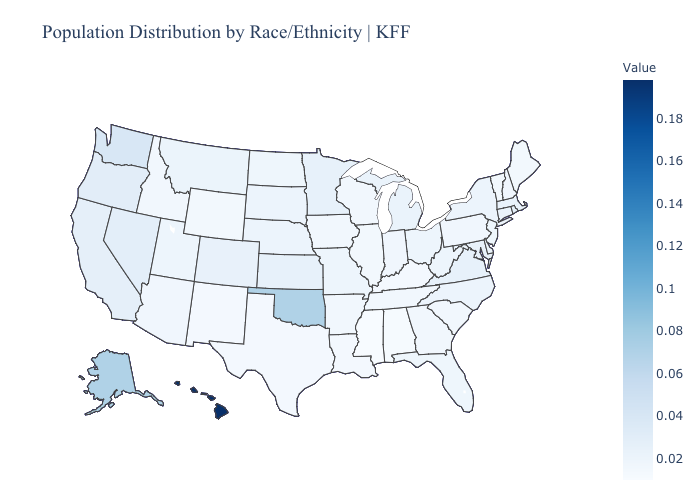Does Alaska have the highest value in the USA?
Short answer required. No. Among the states that border Arkansas , does Oklahoma have the highest value?
Concise answer only. Yes. Does Rhode Island have the highest value in the Northeast?
Concise answer only. Yes. Is the legend a continuous bar?
Answer briefly. Yes. 